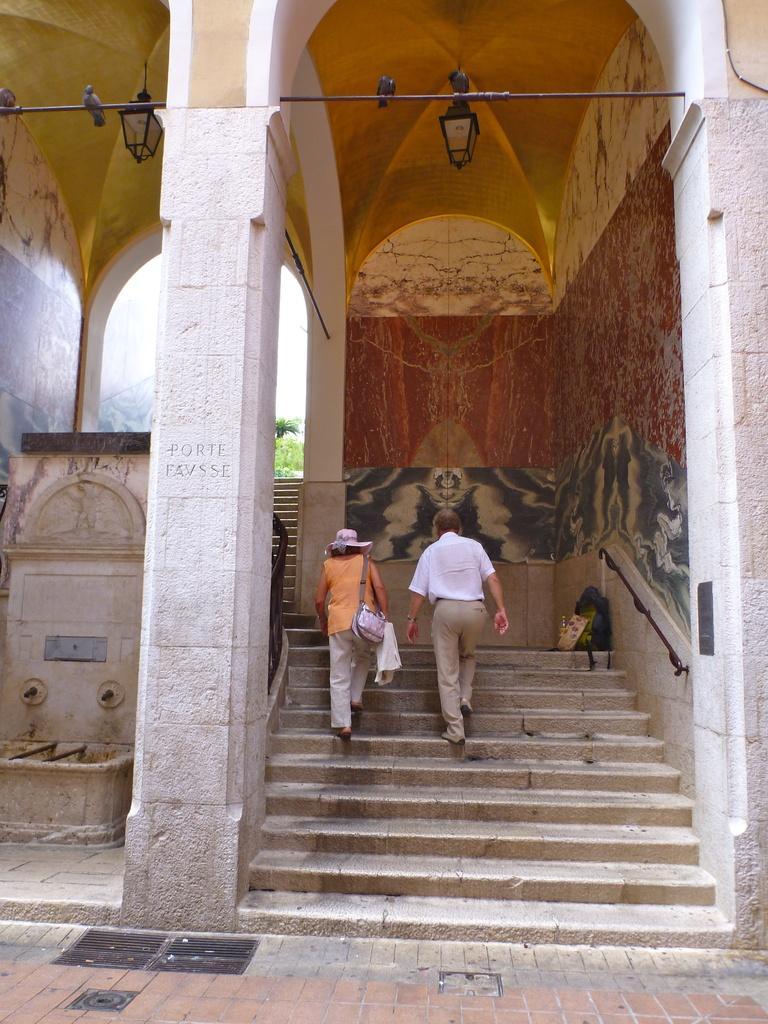How would you summarize this image in a sentence or two? In this picture there is a woman and man in the center of the image, on stairs and there are arches and lamps at the top side of the image and there are birds at the top side of the image, there are taps on the left side of the image and there are paintings on the wall. 